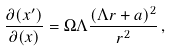<formula> <loc_0><loc_0><loc_500><loc_500>\frac { \partial ( x ^ { \prime } ) } { \partial ( x ) } = \Omega \Lambda \frac { ( \Lambda r + a ) ^ { 2 } } { r ^ { 2 } } \, ,</formula> 